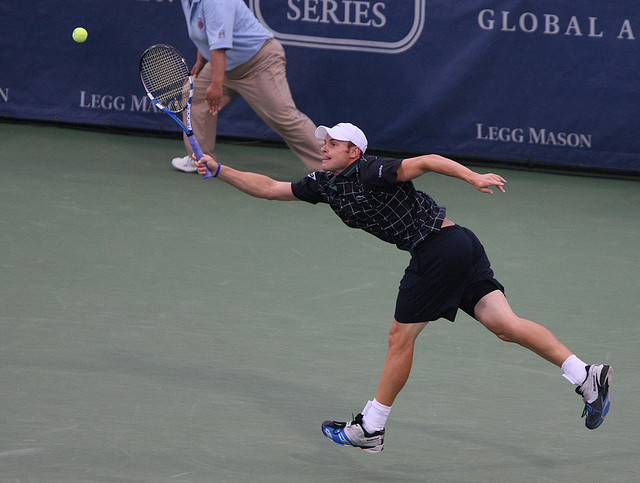Read all the text in this image. GLOBAL LEGG MASON LEGG MA A SERIES 